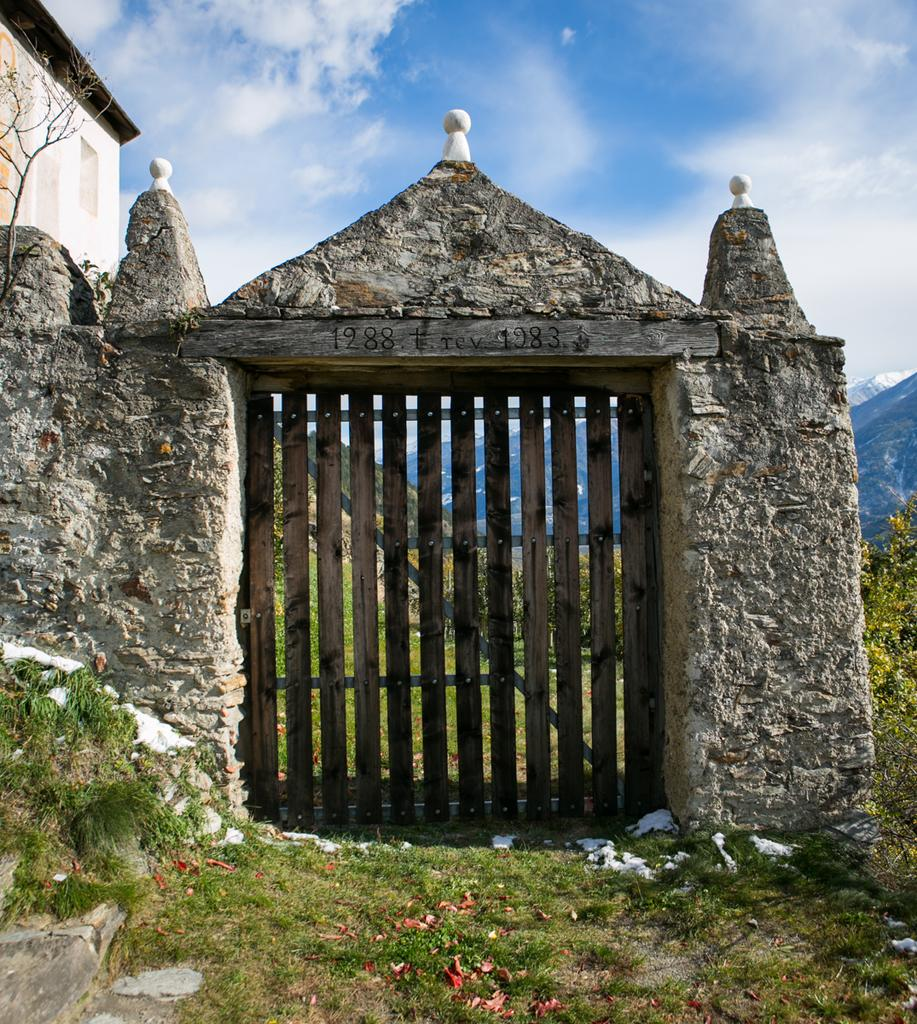What type of structure can be seen in the image? There is a building in the image. What is visible in the background of the image? The sky, clouds, grass, trees, and hills are visible in the background of the image. What type of terrain is present in the image? The image features grass, trees, and hills, indicating a natural landscape. What architectural feature can be seen in the image? There is a gate in the image. What time of day is it in the image, and how can you tell? The time of day cannot be determined from the image, as there are no specific clues such as shadows or lighting to indicate a particular time. Can you see a nest in the trees in the image? There is no nest visible in the trees in the image. 